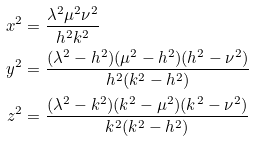<formula> <loc_0><loc_0><loc_500><loc_500>x ^ { 2 } & = \frac { \lambda ^ { 2 } \mu ^ { 2 } \nu ^ { 2 } } { h ^ { 2 } k ^ { 2 } } \\ y ^ { 2 } & = \frac { ( \lambda ^ { 2 } - h ^ { 2 } ) ( \mu ^ { 2 } - h ^ { 2 } ) ( h ^ { 2 } - \nu ^ { 2 } ) } { h ^ { 2 } ( k ^ { 2 } - h ^ { 2 } ) } \\ z ^ { 2 } & = \frac { ( \lambda ^ { 2 } - k ^ { 2 } ) ( k ^ { 2 } - \mu ^ { 2 } ) ( k ^ { 2 } - \nu ^ { 2 } ) } { k ^ { 2 } ( k ^ { 2 } - h ^ { 2 } ) }</formula> 